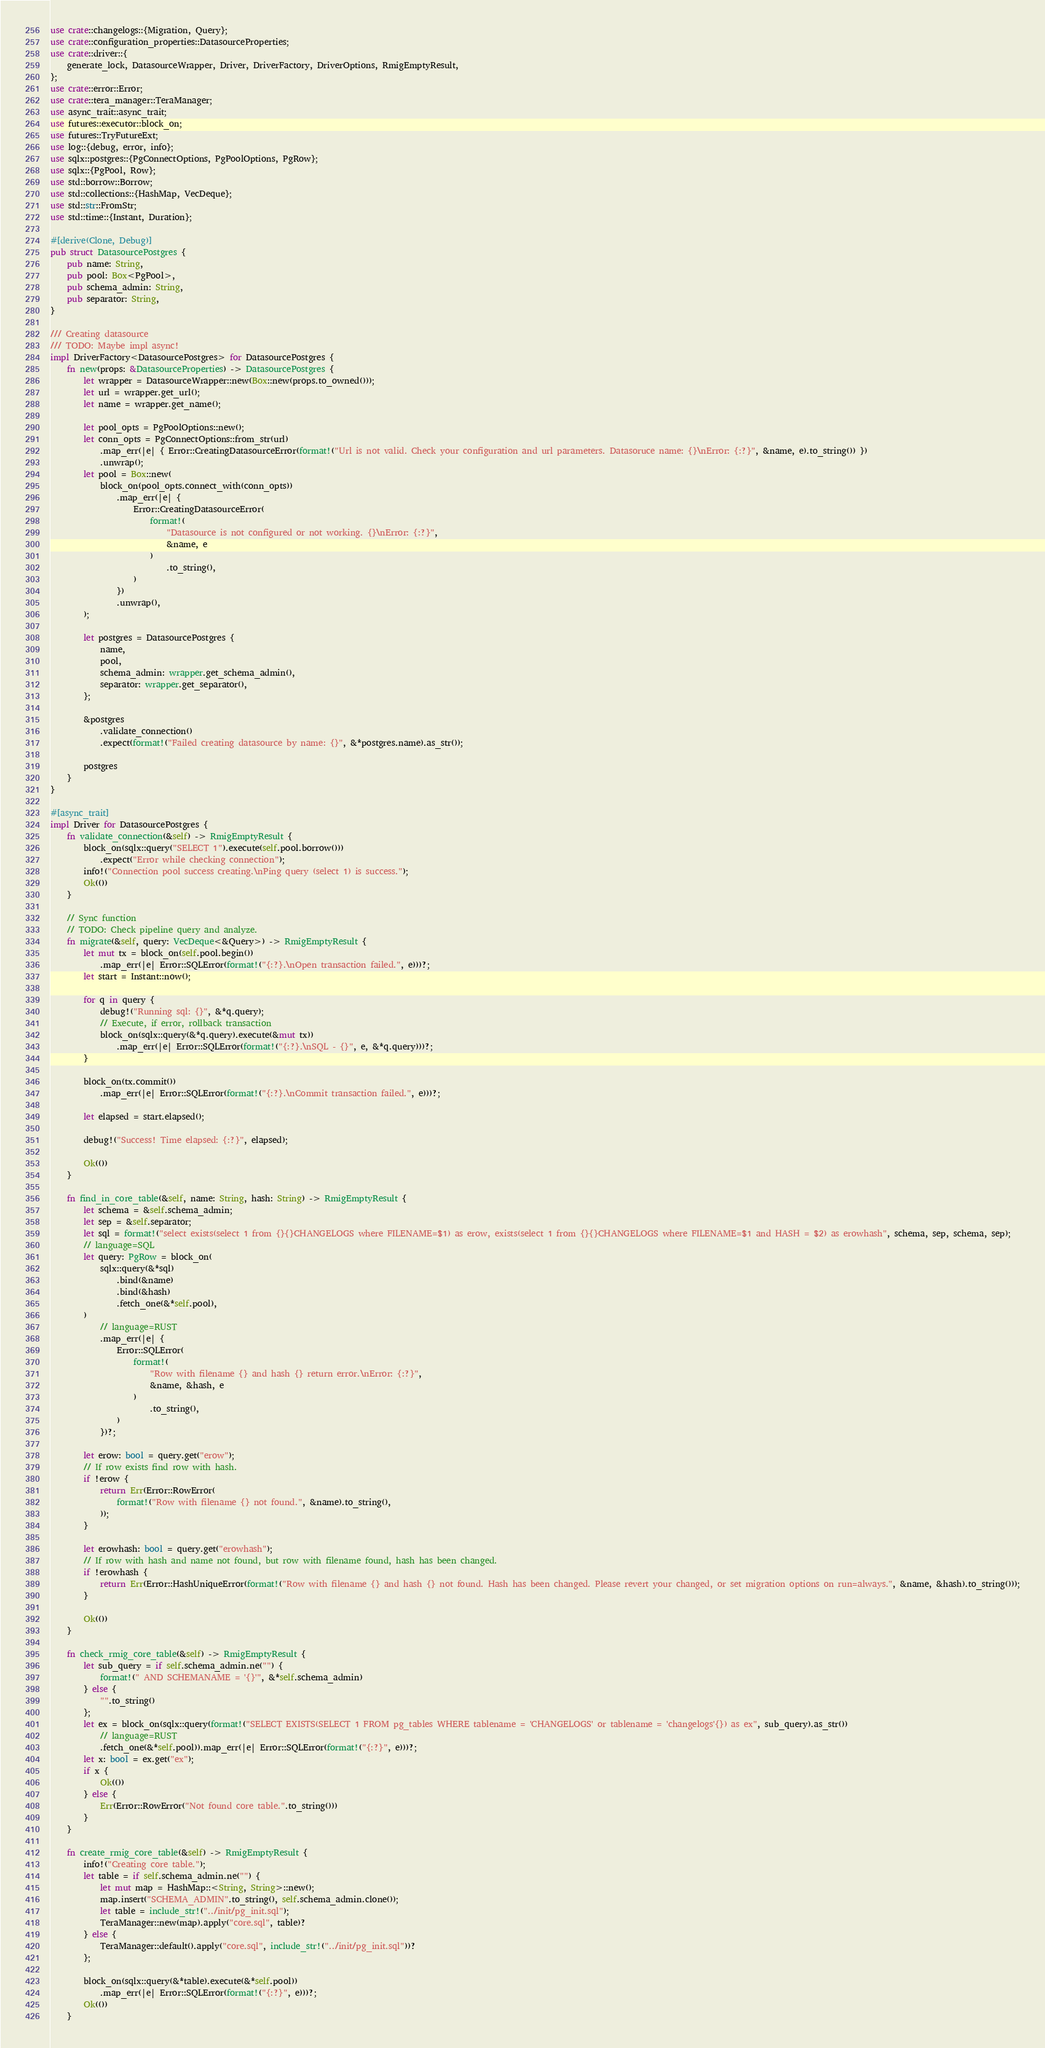Convert code to text. <code><loc_0><loc_0><loc_500><loc_500><_Rust_>use crate::changelogs::{Migration, Query};
use crate::configuration_properties::DatasourceProperties;
use crate::driver::{
    generate_lock, DatasourceWrapper, Driver, DriverFactory, DriverOptions, RmigEmptyResult,
};
use crate::error::Error;
use crate::tera_manager::TeraManager;
use async_trait::async_trait;
use futures::executor::block_on;
use futures::TryFutureExt;
use log::{debug, error, info};
use sqlx::postgres::{PgConnectOptions, PgPoolOptions, PgRow};
use sqlx::{PgPool, Row};
use std::borrow::Borrow;
use std::collections::{HashMap, VecDeque};
use std::str::FromStr;
use std::time::{Instant, Duration};

#[derive(Clone, Debug)]
pub struct DatasourcePostgres {
    pub name: String,
    pub pool: Box<PgPool>,
    pub schema_admin: String,
    pub separator: String,
}

/// Creating datasource
/// TODO: Maybe impl async!
impl DriverFactory<DatasourcePostgres> for DatasourcePostgres {
    fn new(props: &DatasourceProperties) -> DatasourcePostgres {
        let wrapper = DatasourceWrapper::new(Box::new(props.to_owned()));
        let url = wrapper.get_url();
        let name = wrapper.get_name();

        let pool_opts = PgPoolOptions::new();
        let conn_opts = PgConnectOptions::from_str(url)
            .map_err(|e| { Error::CreatingDatasourceError(format!("Url is not valid. Check your configuration and url parameters. Datasoruce name: {}\nError: {:?}", &name, e).to_string()) })
            .unwrap();
        let pool = Box::new(
            block_on(pool_opts.connect_with(conn_opts))
                .map_err(|e| {
                    Error::CreatingDatasourceError(
                        format!(
                            "Datasource is not configured or not working. {}\nError: {:?}",
                            &name, e
                        )
                            .to_string(),
                    )
                })
                .unwrap(),
        );

        let postgres = DatasourcePostgres {
            name,
            pool,
            schema_admin: wrapper.get_schema_admin(),
            separator: wrapper.get_separator(),
        };

        &postgres
            .validate_connection()
            .expect(format!("Failed creating datasource by name: {}", &*postgres.name).as_str());

        postgres
    }
}

#[async_trait]
impl Driver for DatasourcePostgres {
    fn validate_connection(&self) -> RmigEmptyResult {
        block_on(sqlx::query("SELECT 1").execute(self.pool.borrow()))
            .expect("Error while checking connection");
        info!("Connection pool success creating.\nPing query (select 1) is success.");
        Ok(())
    }

    // Sync function
    // TODO: Check pipeline query and analyze.
    fn migrate(&self, query: VecDeque<&Query>) -> RmigEmptyResult {
        let mut tx = block_on(self.pool.begin())
            .map_err(|e| Error::SQLError(format!("{:?}.\nOpen transaction failed.", e)))?;
        let start = Instant::now();

        for q in query {
            debug!("Running sql: {}", &*q.query);
            // Execute, if error, rollback transaction
            block_on(sqlx::query(&*q.query).execute(&mut tx))
                .map_err(|e| Error::SQLError(format!("{:?}.\nSQL - {}", e, &*q.query)))?;
        }

        block_on(tx.commit())
            .map_err(|e| Error::SQLError(format!("{:?}.\nCommit transaction failed.", e)))?;

        let elapsed = start.elapsed();

        debug!("Success! Time elapsed: {:?}", elapsed);

        Ok(())
    }

    fn find_in_core_table(&self, name: String, hash: String) -> RmigEmptyResult {
        let schema = &self.schema_admin;
        let sep = &self.separator;
        let sql = format!("select exists(select 1 from {}{}CHANGELOGS where FILENAME=$1) as erow, exists(select 1 from {}{}CHANGELOGS where FILENAME=$1 and HASH = $2) as erowhash", schema, sep, schema, sep);
        // language=SQL
        let query: PgRow = block_on(
            sqlx::query(&*sql)
                .bind(&name)
                .bind(&hash)
                .fetch_one(&*self.pool),
        )
            // language=RUST
            .map_err(|e| {
                Error::SQLError(
                    format!(
                        "Row with filename {} and hash {} return error.\nError: {:?}",
                        &name, &hash, e
                    )
                        .to_string(),
                )
            })?;

        let erow: bool = query.get("erow");
        // If row exists find row with hash.
        if !erow {
            return Err(Error::RowError(
                format!("Row with filename {} not found.", &name).to_string(),
            ));
        }

        let erowhash: bool = query.get("erowhash");
        // If row with hash and name not found, but row with filename found, hash has been changed.
        if !erowhash {
            return Err(Error::HashUniqueError(format!("Row with filename {} and hash {} not found. Hash has been changed. Please revert your changed, or set migration options on run=always.", &name, &hash).to_string()));
        }

        Ok(())
    }

    fn check_rmig_core_table(&self) -> RmigEmptyResult {
        let sub_query = if self.schema_admin.ne("") {
            format!(" AND SCHEMANAME = '{}'", &*self.schema_admin)
        } else {
            "".to_string()
        };
        let ex = block_on(sqlx::query(format!("SELECT EXISTS(SELECT 1 FROM pg_tables WHERE tablename = 'CHANGELOGS' or tablename = 'changelogs'{}) as ex", sub_query).as_str())
            // language=RUST
            .fetch_one(&*self.pool)).map_err(|e| Error::SQLError(format!("{:?}", e)))?;
        let x: bool = ex.get("ex");
        if x {
            Ok(())
        } else {
            Err(Error::RowError("Not found core table.".to_string()))
        }
    }

    fn create_rmig_core_table(&self) -> RmigEmptyResult {
        info!("Creating core table.");
        let table = if self.schema_admin.ne("") {
            let mut map = HashMap::<String, String>::new();
            map.insert("SCHEMA_ADMIN".to_string(), self.schema_admin.clone());
            let table = include_str!("../init/pg_init.sql");
            TeraManager::new(map).apply("core.sql", table)?
        } else {
            TeraManager::default().apply("core.sql", include_str!("../init/pg_init.sql"))?
        };

        block_on(sqlx::query(&*table).execute(&*self.pool))
            .map_err(|e| Error::SQLError(format!("{:?}", e)))?;
        Ok(())
    }
</code> 